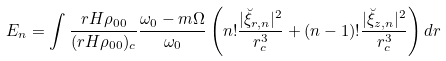<formula> <loc_0><loc_0><loc_500><loc_500>E _ { n } = \int \frac { r H \rho _ { 0 0 } } { ( r H \rho _ { 0 0 } ) _ { c } } \frac { \omega _ { 0 } - m \Omega } { \omega _ { 0 } } \left ( n ! \frac { | \breve { \xi } _ { r , n } | ^ { 2 } } { r _ { c } ^ { 3 } } + ( n - 1 ) ! \frac { | \breve { \xi } _ { z , n } | ^ { 2 } } { r _ { c } ^ { 3 } } \right ) d r</formula> 